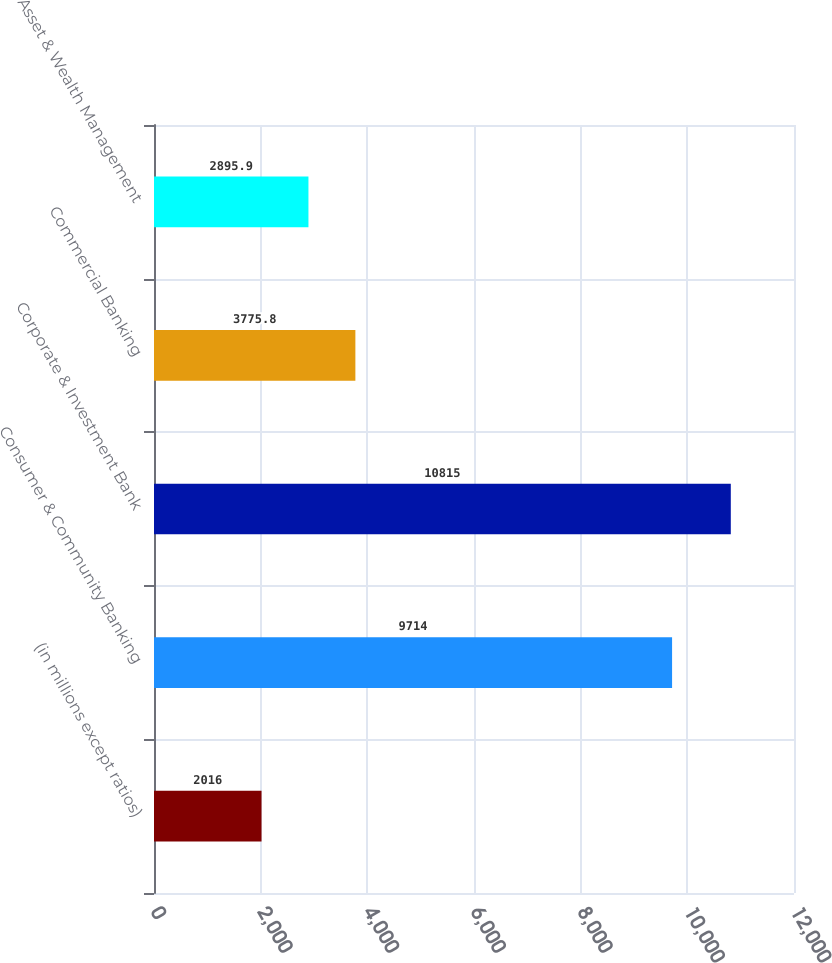Convert chart to OTSL. <chart><loc_0><loc_0><loc_500><loc_500><bar_chart><fcel>(in millions except ratios)<fcel>Consumer & Community Banking<fcel>Corporate & Investment Bank<fcel>Commercial Banking<fcel>Asset & Wealth Management<nl><fcel>2016<fcel>9714<fcel>10815<fcel>3775.8<fcel>2895.9<nl></chart> 